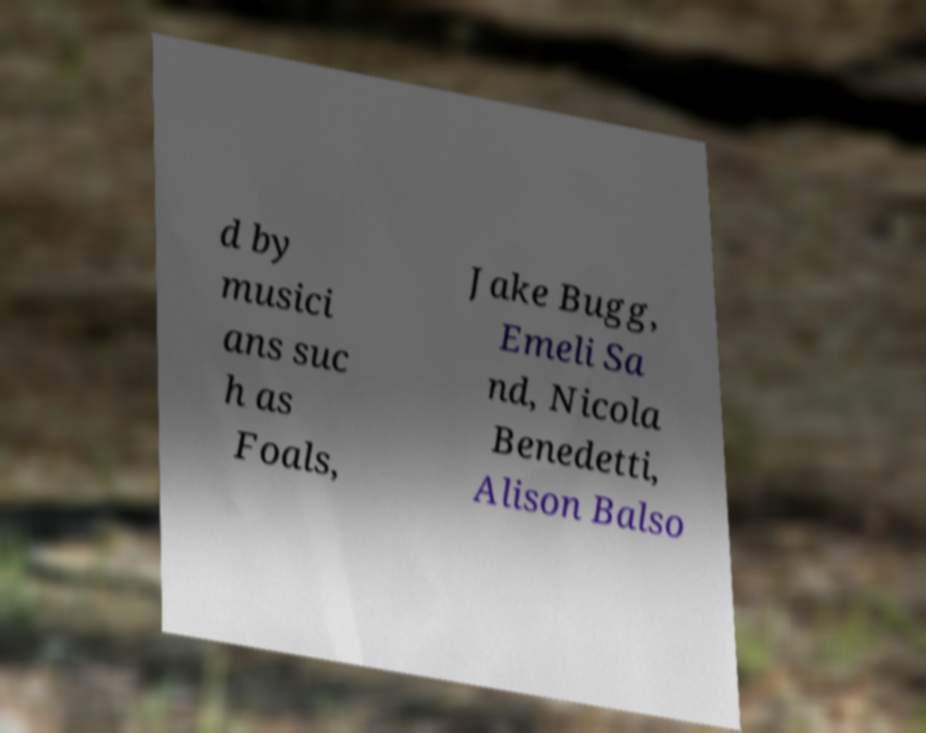Can you read and provide the text displayed in the image?This photo seems to have some interesting text. Can you extract and type it out for me? d by musici ans suc h as Foals, Jake Bugg, Emeli Sa nd, Nicola Benedetti, Alison Balso 